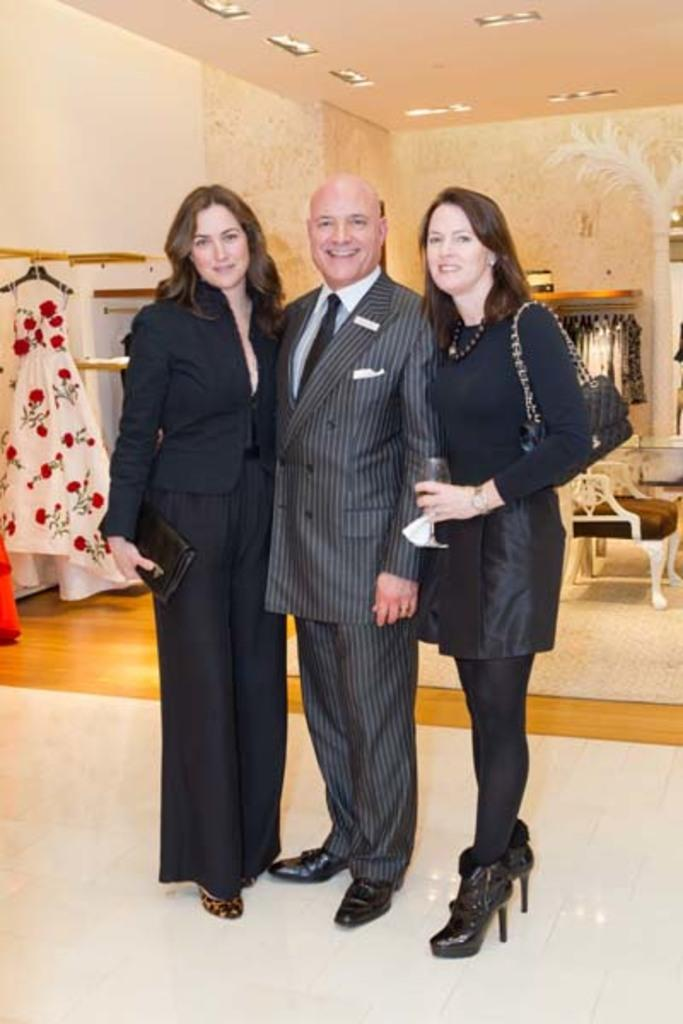How many people are in the image? There is a man and two women in the image, making a total of three people. What are the people doing in the image? The people are standing on the floor and smiling. What can be seen in the background of the image? There are clothes, a chair, a wall, and lights in the background of the image. What type of organization is the man representing in the image? There is no indication in the image that the man is representing any organization. What kind of art can be seen hanging on the wall in the image? There is no art visible on the wall in the image. 